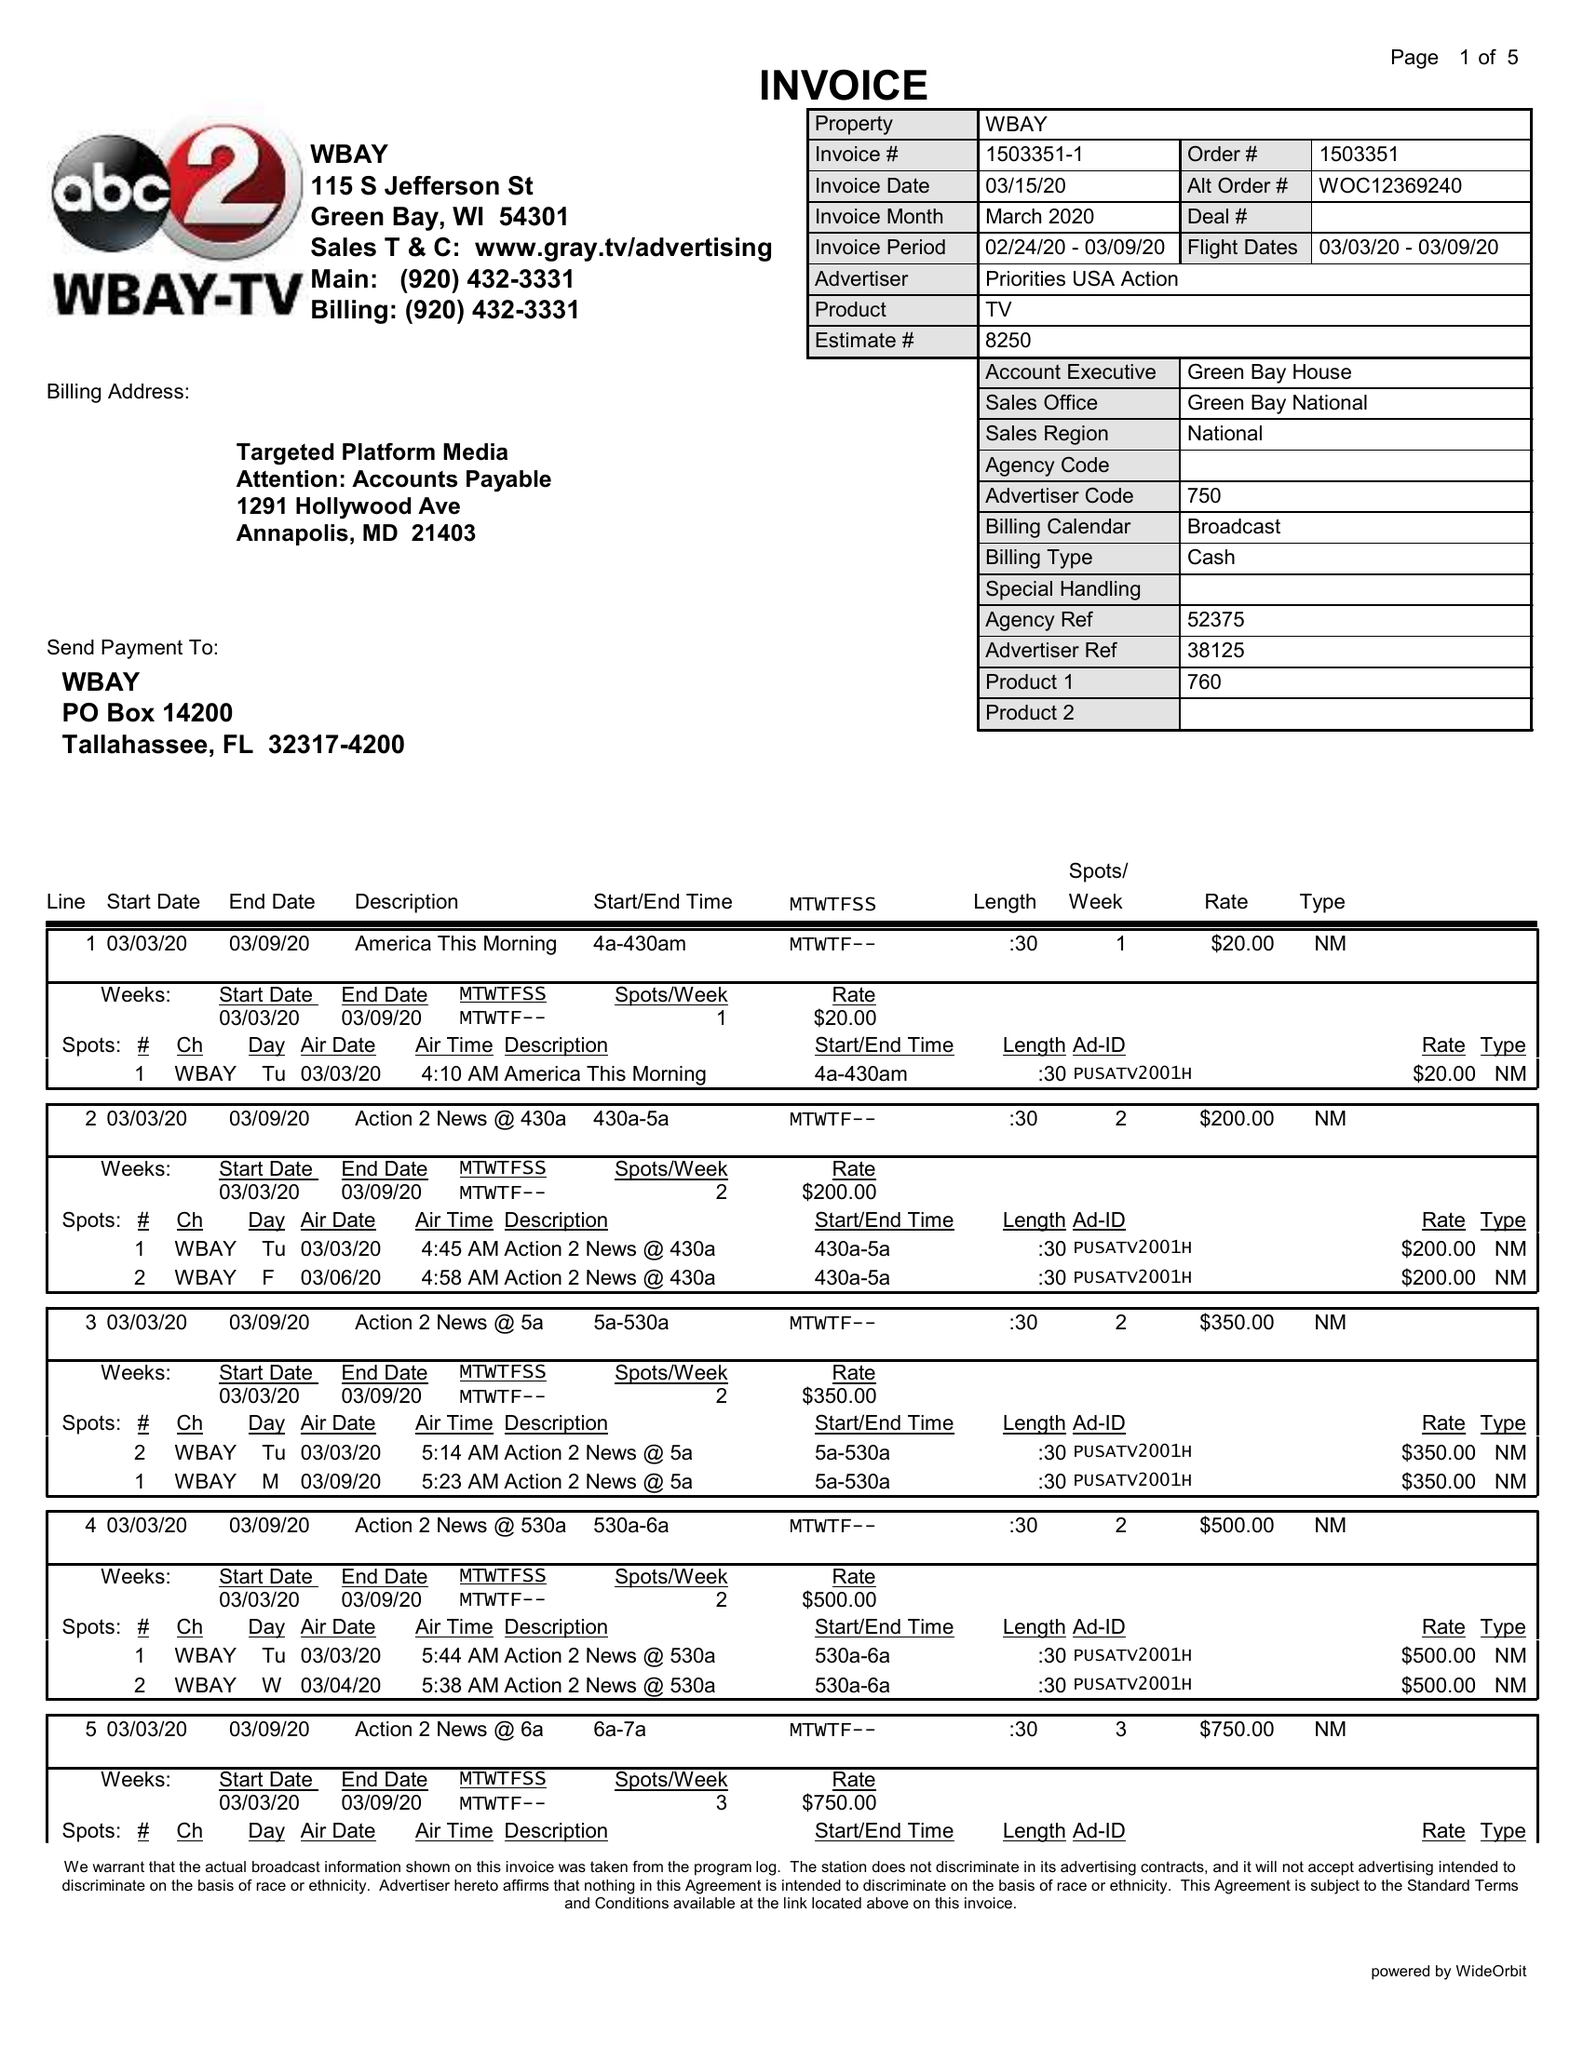What is the value for the flight_to?
Answer the question using a single word or phrase. 03/09/20 